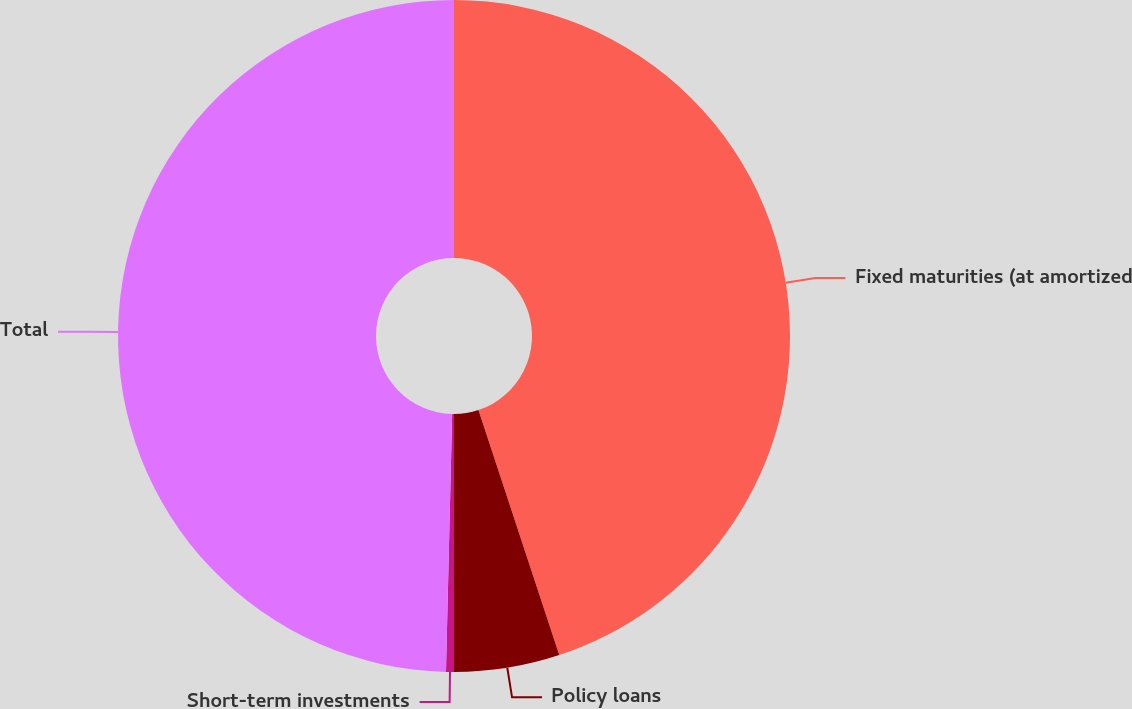<chart> <loc_0><loc_0><loc_500><loc_500><pie_chart><fcel>Fixed maturities (at amortized<fcel>Policy loans<fcel>Short-term investments<fcel>Total<nl><fcel>44.93%<fcel>5.07%<fcel>0.38%<fcel>49.62%<nl></chart> 